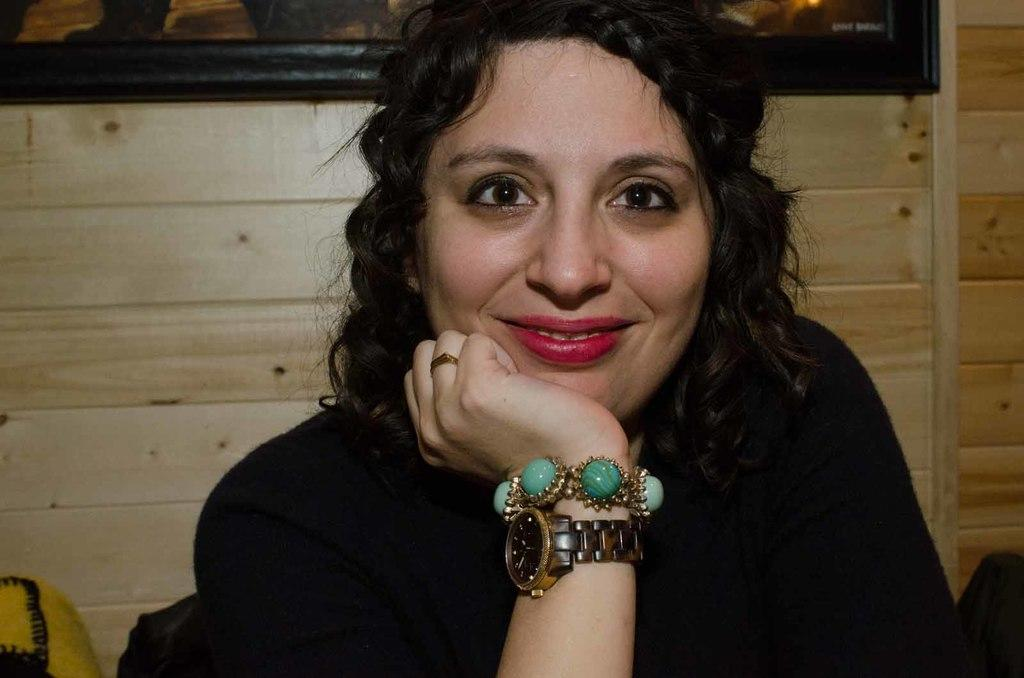Who is the main subject in the image? There is a girl in the image. What is the girl doing in the image? The girl is looking at the camera. What can be seen on the wooden wall in the image? There is a frame hanging on the wooden wall in the image. What type of wine is being exchanged between the girl and the person behind the camera? There is no wine or exchange of any kind depicted in the image; it only shows the girl looking at the camera. 